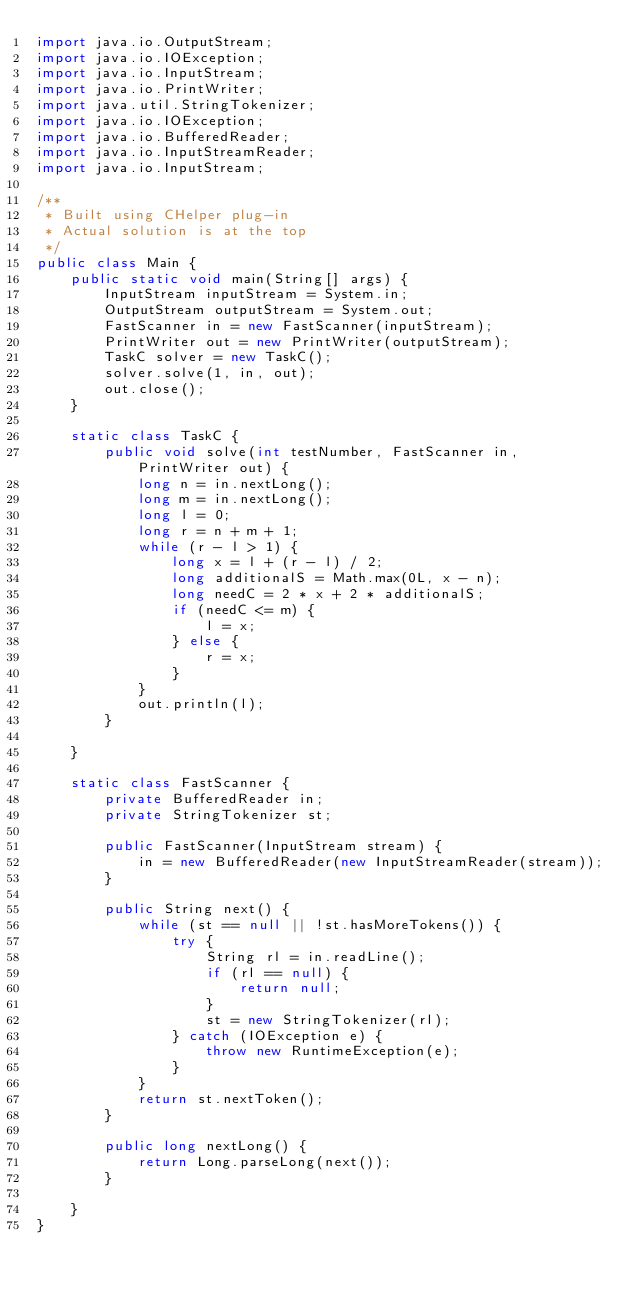<code> <loc_0><loc_0><loc_500><loc_500><_Java_>import java.io.OutputStream;
import java.io.IOException;
import java.io.InputStream;
import java.io.PrintWriter;
import java.util.StringTokenizer;
import java.io.IOException;
import java.io.BufferedReader;
import java.io.InputStreamReader;
import java.io.InputStream;

/**
 * Built using CHelper plug-in
 * Actual solution is at the top
 */
public class Main {
	public static void main(String[] args) {
		InputStream inputStream = System.in;
		OutputStream outputStream = System.out;
		FastScanner in = new FastScanner(inputStream);
		PrintWriter out = new PrintWriter(outputStream);
		TaskC solver = new TaskC();
		solver.solve(1, in, out);
		out.close();
	}

	static class TaskC {
		public void solve(int testNumber, FastScanner in, PrintWriter out) {
			long n = in.nextLong();
			long m = in.nextLong();
			long l = 0;
			long r = n + m + 1;
			while (r - l > 1) {
				long x = l + (r - l) / 2;
				long additionalS = Math.max(0L, x - n);
				long needC = 2 * x + 2 * additionalS;
				if (needC <= m) {
					l = x;
				} else {
					r = x;
				}
			}
			out.println(l);
		}

	}

	static class FastScanner {
		private BufferedReader in;
		private StringTokenizer st;

		public FastScanner(InputStream stream) {
			in = new BufferedReader(new InputStreamReader(stream));
		}

		public String next() {
			while (st == null || !st.hasMoreTokens()) {
				try {
					String rl = in.readLine();
					if (rl == null) {
						return null;
					}
					st = new StringTokenizer(rl);
				} catch (IOException e) {
					throw new RuntimeException(e);
				}
			}
			return st.nextToken();
		}

		public long nextLong() {
			return Long.parseLong(next());
		}

	}
}

</code> 